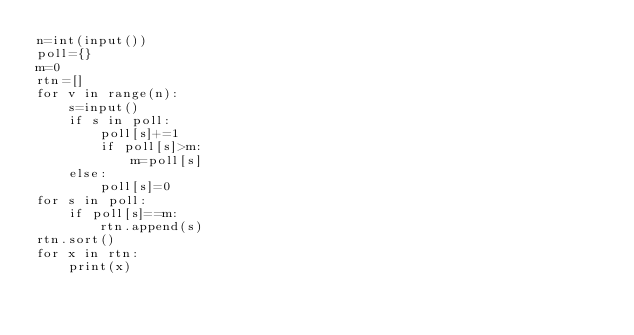Convert code to text. <code><loc_0><loc_0><loc_500><loc_500><_Python_>n=int(input())
poll={}
m=0
rtn=[]
for v in range(n):
    s=input()
    if s in poll:
        poll[s]+=1
        if poll[s]>m:
            m=poll[s]
    else:
        poll[s]=0
for s in poll:
    if poll[s]==m:
        rtn.append(s)
rtn.sort()
for x in rtn:
    print(x)
        
    
</code> 